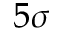<formula> <loc_0><loc_0><loc_500><loc_500>5 \sigma</formula> 